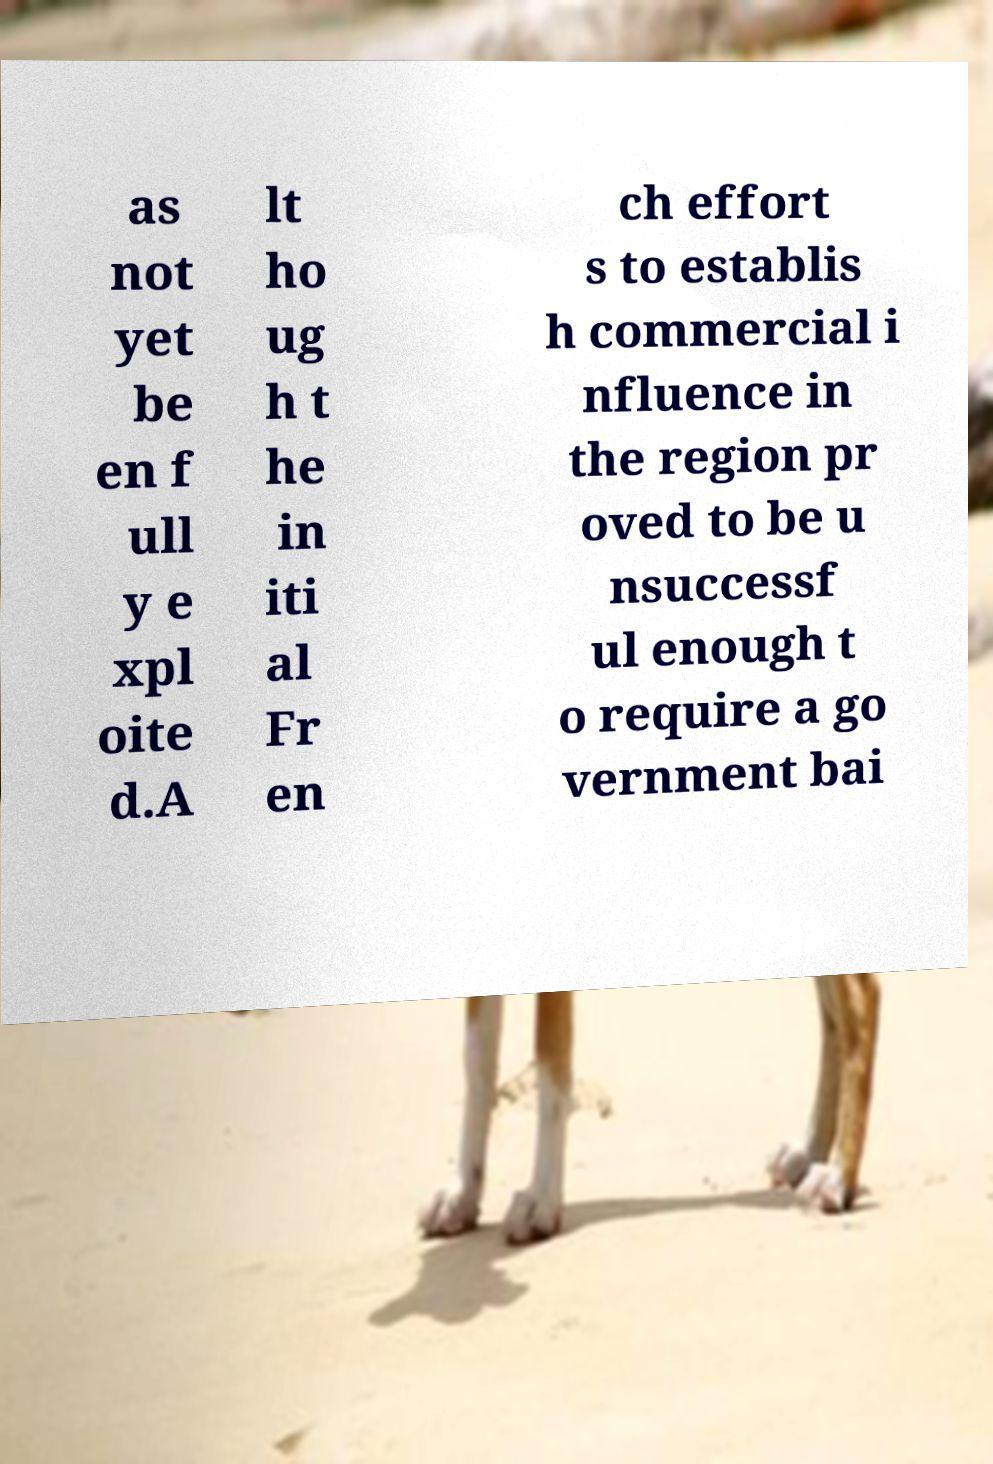Can you read and provide the text displayed in the image?This photo seems to have some interesting text. Can you extract and type it out for me? as not yet be en f ull y e xpl oite d.A lt ho ug h t he in iti al Fr en ch effort s to establis h commercial i nfluence in the region pr oved to be u nsuccessf ul enough t o require a go vernment bai 